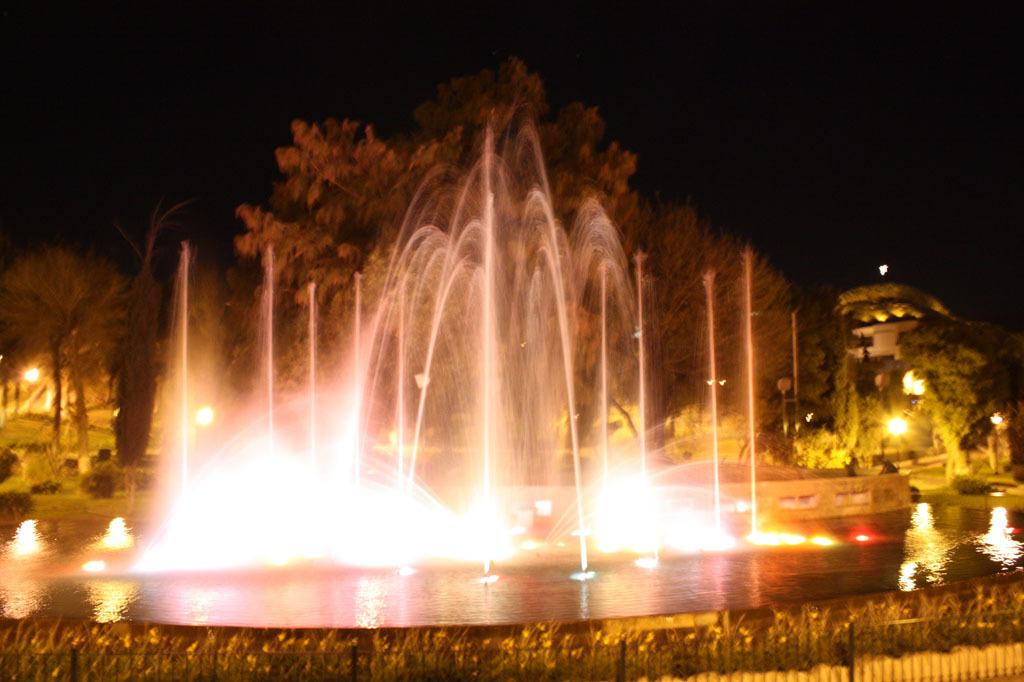What type of structure can be seen in the image? There is fencing in the image. What is located outside the fencing? There are plants outside the fencing. What natural features are visible in the background of the image? There are waterfalls and trees in the background of the image. What type of illumination is present in the background of the image? There are lights in the background of the image. How would you describe the overall color of the background in the image? The background of the image is dark in color. What type of country music can be heard playing in the background of the image? There is no music or sound present in the image, so it is not possible to determine what type of country music might be playing. 